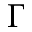Convert formula to latex. <formula><loc_0><loc_0><loc_500><loc_500>\Gamma</formula> 